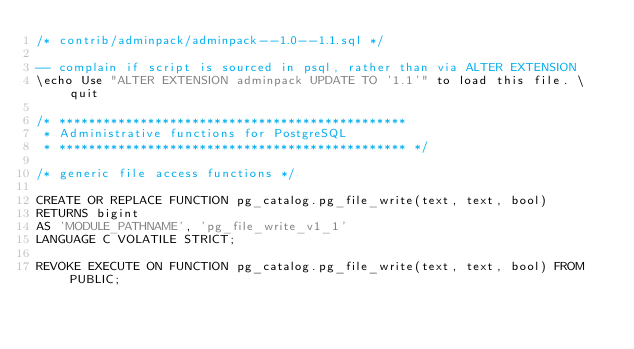Convert code to text. <code><loc_0><loc_0><loc_500><loc_500><_SQL_>/* contrib/adminpack/adminpack--1.0--1.1.sql */

-- complain if script is sourced in psql, rather than via ALTER EXTENSION
\echo Use "ALTER EXTENSION adminpack UPDATE TO '1.1'" to load this file. \quit

/* ***********************************************
 * Administrative functions for PostgreSQL
 * *********************************************** */

/* generic file access functions */

CREATE OR REPLACE FUNCTION pg_catalog.pg_file_write(text, text, bool)
RETURNS bigint
AS 'MODULE_PATHNAME', 'pg_file_write_v1_1'
LANGUAGE C VOLATILE STRICT;

REVOKE EXECUTE ON FUNCTION pg_catalog.pg_file_write(text, text, bool) FROM PUBLIC;
</code> 